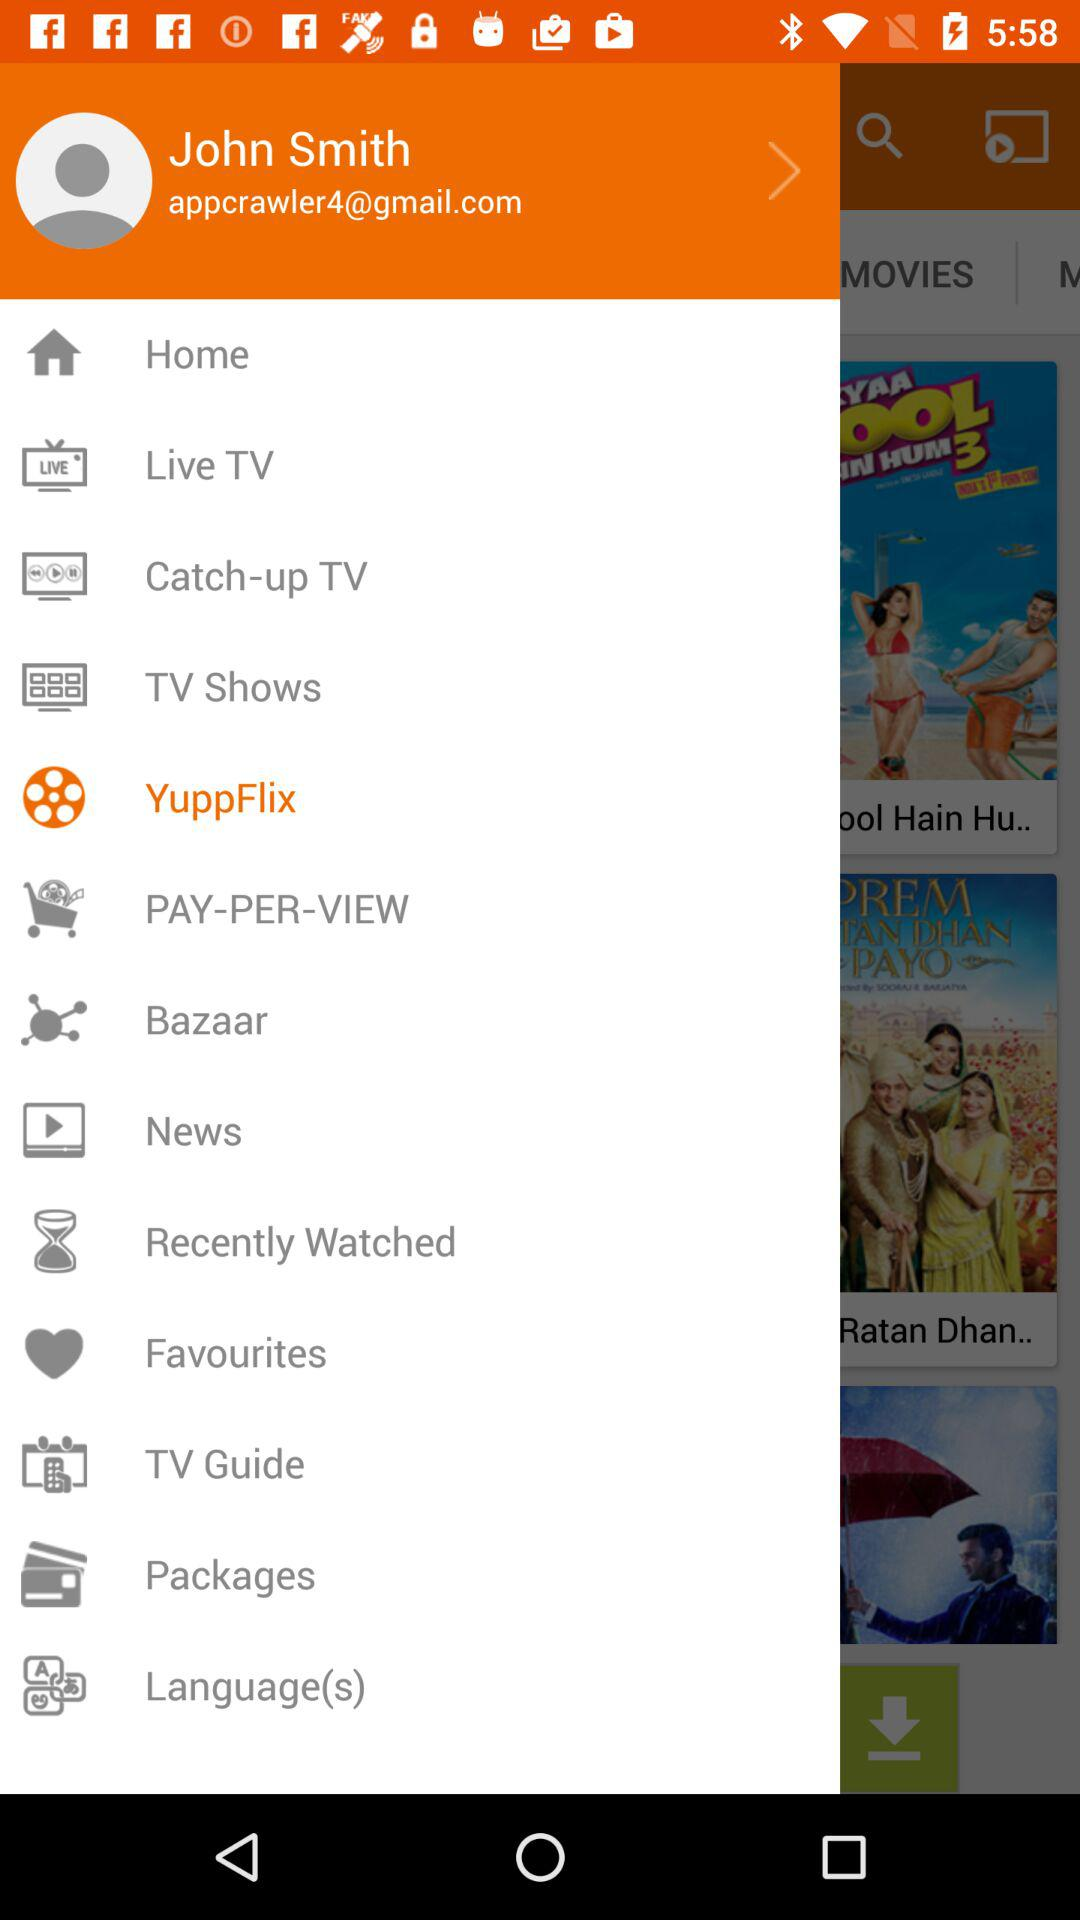What is the Gmail account? The Gmail account is appcrawler4@gmail.com. 